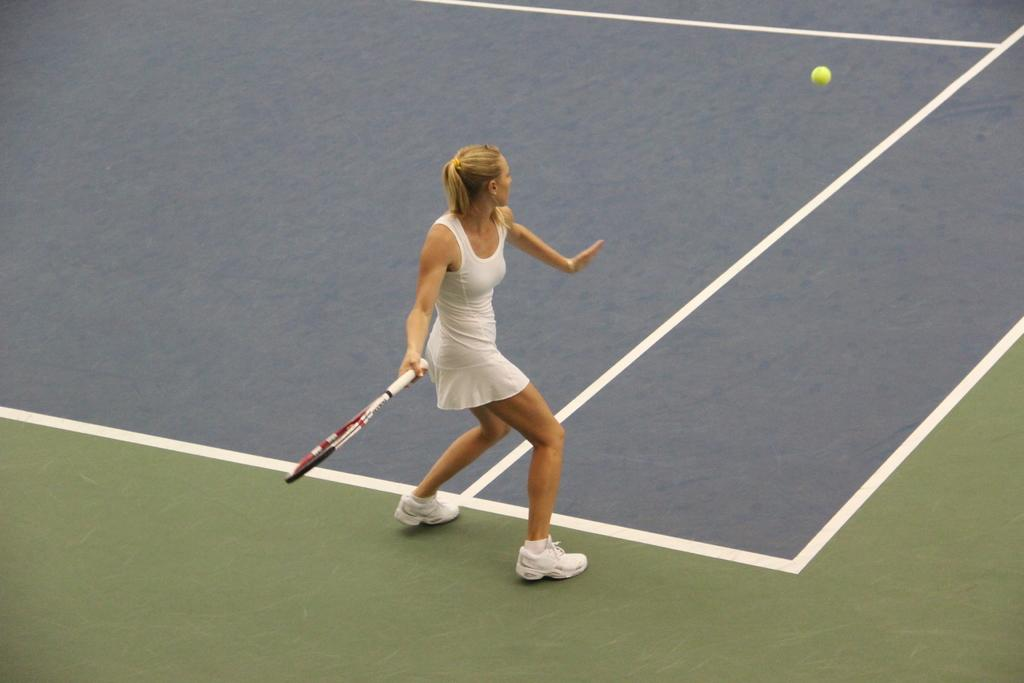Who is present in the image? There is a woman in the image. What is the woman holding in the image? The woman is holding a bat. Where is the woman located in the image? The woman is on a court. What else can be seen in the image besides the woman and her bat? There is a ball visible in the image. What type of bird is flying over the court in the image? There is no bird visible in the image; it only features a woman, a bat, a court, and a ball. 